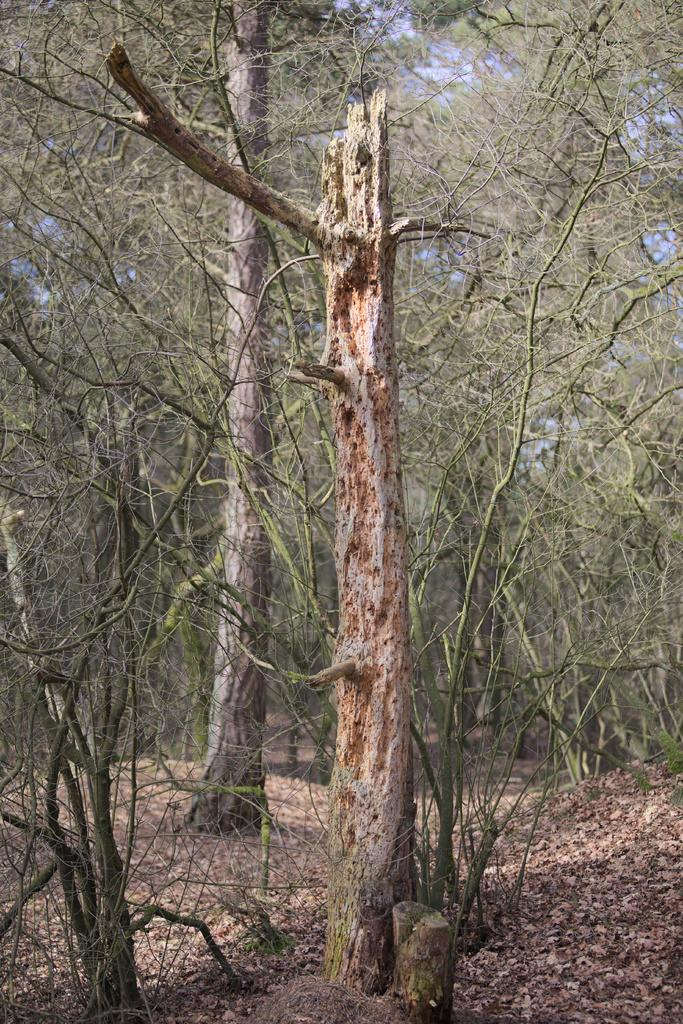What type of surface is visible in the image? There is ground visible in the image. What can be found on the ground in the image? There are leaves on the ground. What type of vegetation is present in the image? There are trees in the image. Can you see a giraffe standing near the trees in the image? No, there is no giraffe present in the image. What type of sign can be seen on the ground in the image? There is no sign visible on the ground in the image. 